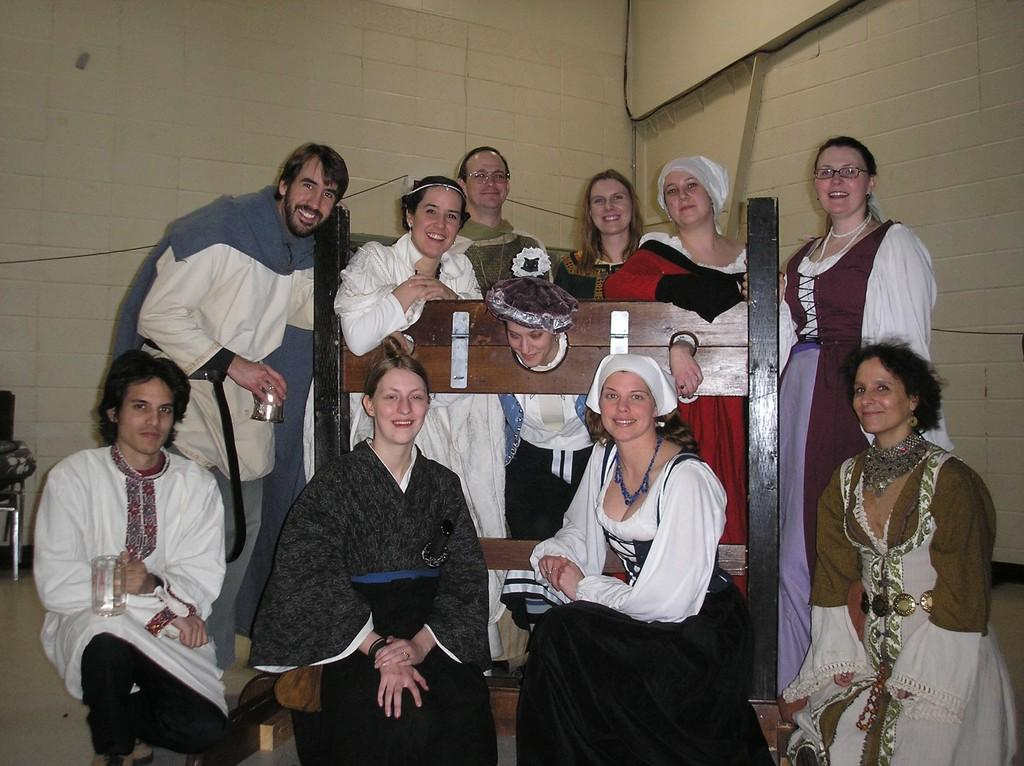Who or what can be seen in the image? There are people in the image. What type of object is made of wood and visible in the image? There is a wooden object in the image. What is in the background of the image? There is a wall in the background of the image. What is at the bottom of the image? There is a floor at the bottom of the image. What type of organization is depicted in the image? There is no organization depicted in the image; it features people and a wooden object in front of a wall. Can you hear a whistle in the image? There is no whistle present in the image; it is a visual representation without any sound. 